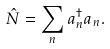<formula> <loc_0><loc_0><loc_500><loc_500>\hat { N } = \sum _ { n } a ^ { \dagger } _ { n } a _ { n } .</formula> 